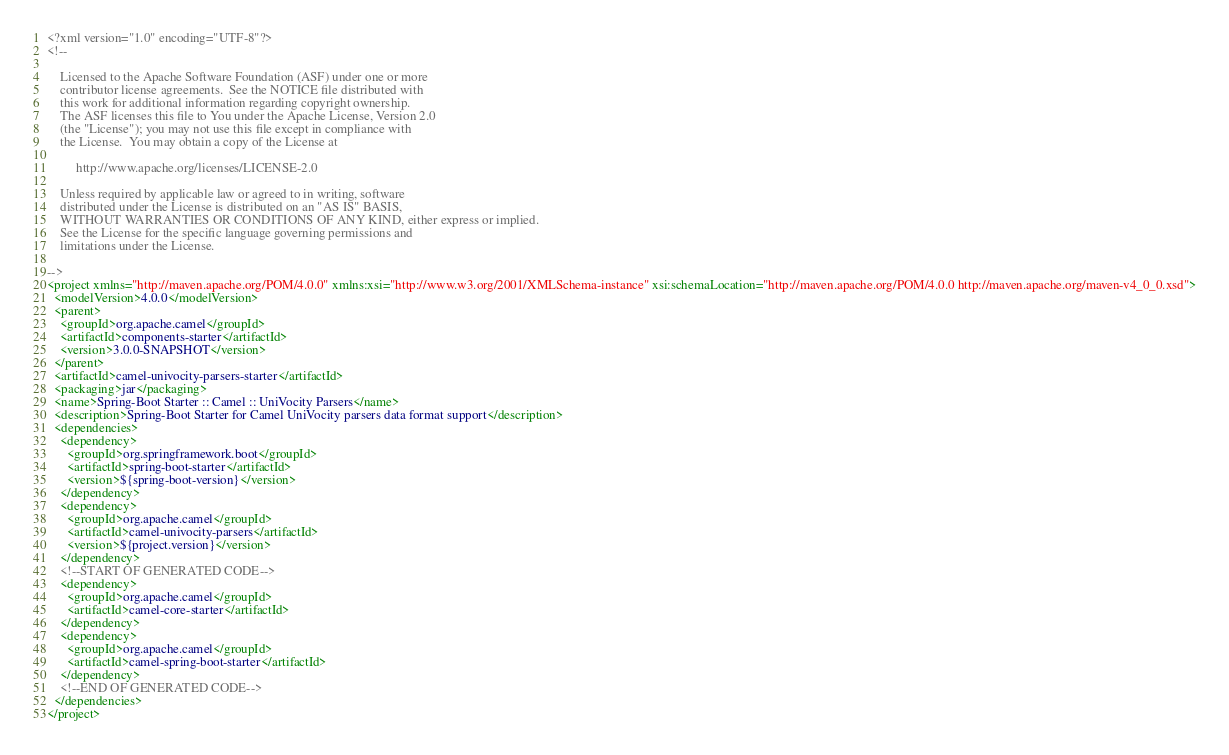<code> <loc_0><loc_0><loc_500><loc_500><_XML_><?xml version="1.0" encoding="UTF-8"?>
<!--

    Licensed to the Apache Software Foundation (ASF) under one or more
    contributor license agreements.  See the NOTICE file distributed with
    this work for additional information regarding copyright ownership.
    The ASF licenses this file to You under the Apache License, Version 2.0
    (the "License"); you may not use this file except in compliance with
    the License.  You may obtain a copy of the License at

         http://www.apache.org/licenses/LICENSE-2.0

    Unless required by applicable law or agreed to in writing, software
    distributed under the License is distributed on an "AS IS" BASIS,
    WITHOUT WARRANTIES OR CONDITIONS OF ANY KIND, either express or implied.
    See the License for the specific language governing permissions and
    limitations under the License.

-->
<project xmlns="http://maven.apache.org/POM/4.0.0" xmlns:xsi="http://www.w3.org/2001/XMLSchema-instance" xsi:schemaLocation="http://maven.apache.org/POM/4.0.0 http://maven.apache.org/maven-v4_0_0.xsd">
  <modelVersion>4.0.0</modelVersion>
  <parent>
    <groupId>org.apache.camel</groupId>
    <artifactId>components-starter</artifactId>
    <version>3.0.0-SNAPSHOT</version>
  </parent>
  <artifactId>camel-univocity-parsers-starter</artifactId>
  <packaging>jar</packaging>
  <name>Spring-Boot Starter :: Camel :: UniVocity Parsers</name>
  <description>Spring-Boot Starter for Camel UniVocity parsers data format support</description>
  <dependencies>
    <dependency>
      <groupId>org.springframework.boot</groupId>
      <artifactId>spring-boot-starter</artifactId>
      <version>${spring-boot-version}</version>
    </dependency>
    <dependency>
      <groupId>org.apache.camel</groupId>
      <artifactId>camel-univocity-parsers</artifactId>
      <version>${project.version}</version>
    </dependency>
    <!--START OF GENERATED CODE-->
    <dependency>
      <groupId>org.apache.camel</groupId>
      <artifactId>camel-core-starter</artifactId>
    </dependency>
    <dependency>
      <groupId>org.apache.camel</groupId>
      <artifactId>camel-spring-boot-starter</artifactId>
    </dependency>
    <!--END OF GENERATED CODE-->
  </dependencies>
</project>
</code> 